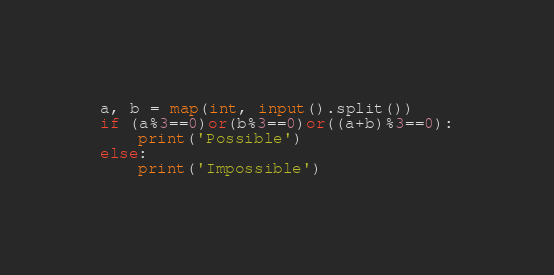<code> <loc_0><loc_0><loc_500><loc_500><_Python_>a, b = map(int, input().split())
if (a%3==0)or(b%3==0)or((a+b)%3==0):
    print('Possible')
else:
    print('Impossible')</code> 